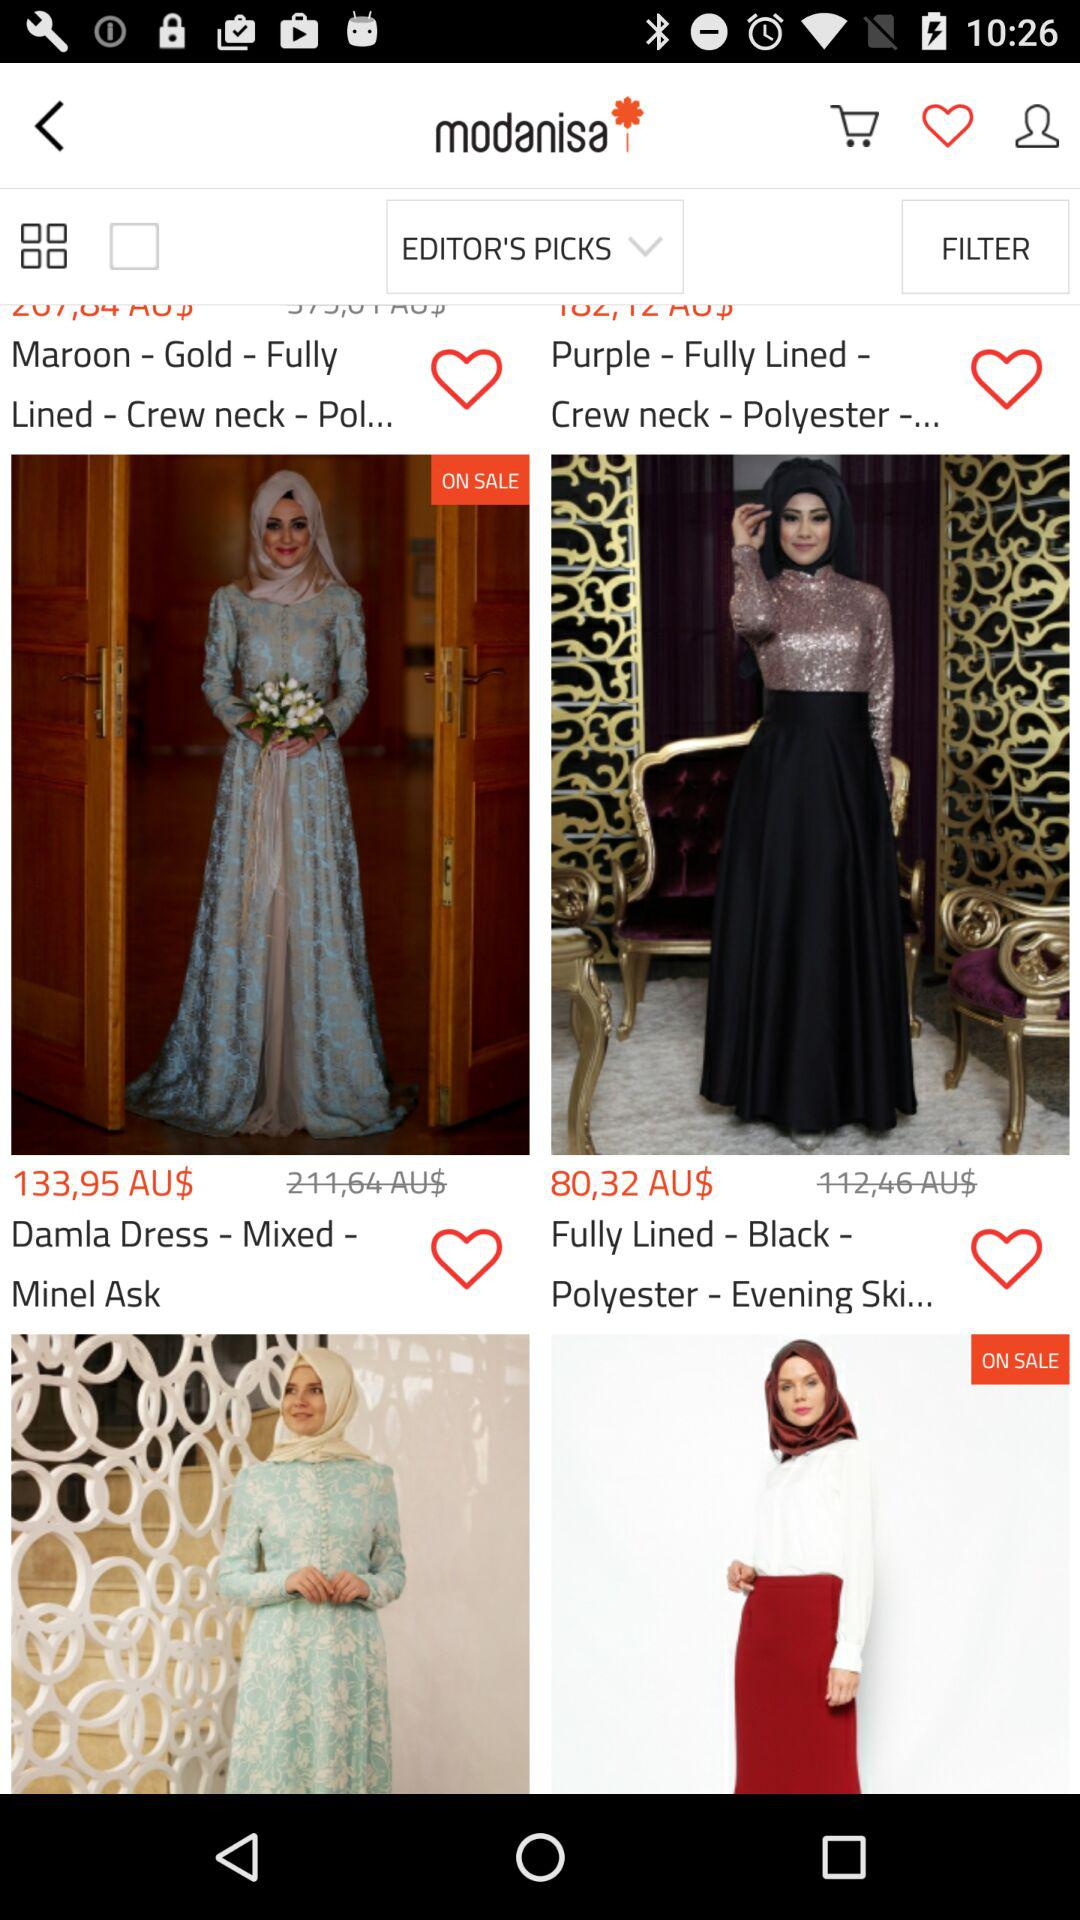How much is the discounted price of "Fully Lined - Black"? The discounted price is 80,32 Australian dollars. 